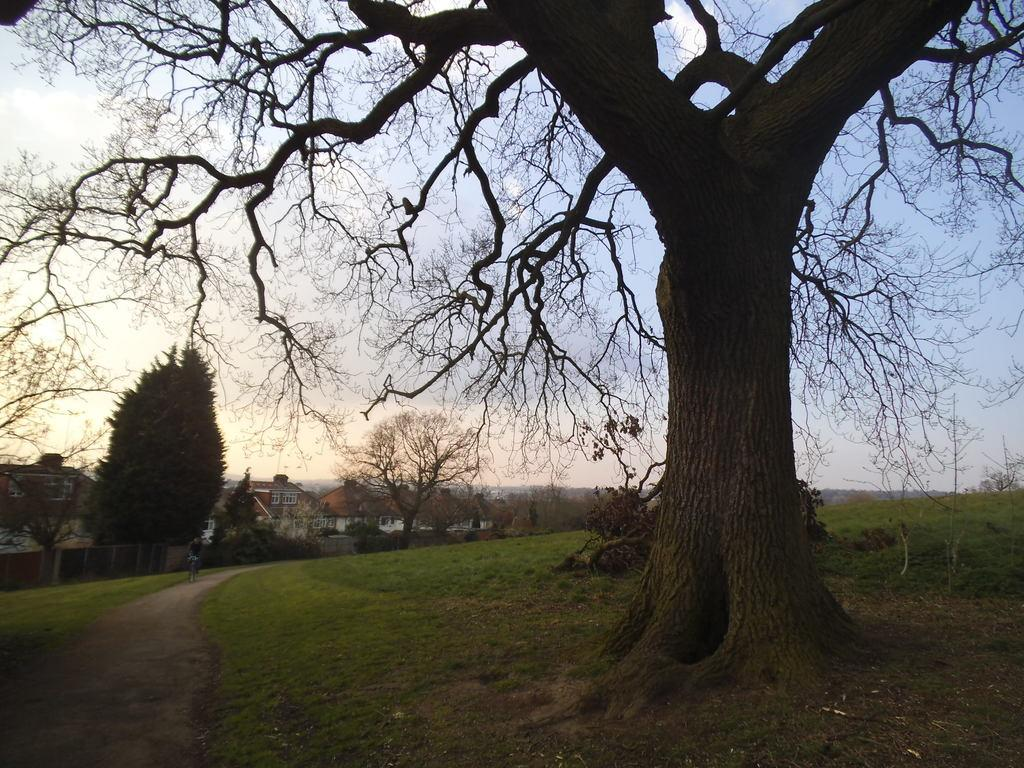What can be seen in the background of the image? In the background of the image, there is sky, houses, trees, and a person riding a bicycle. What type of terrain is visible in the image? Grass is visible in the image. How many beggars can be seen holding a pail in the image? There are no beggars or pails present in the image. 